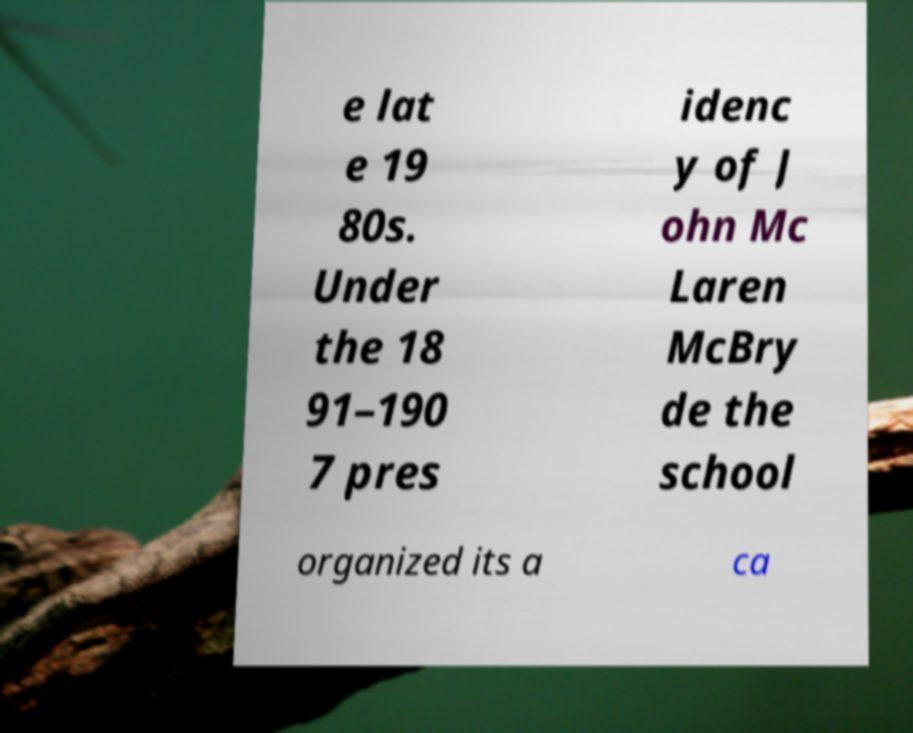Can you accurately transcribe the text from the provided image for me? e lat e 19 80s. Under the 18 91–190 7 pres idenc y of J ohn Mc Laren McBry de the school organized its a ca 